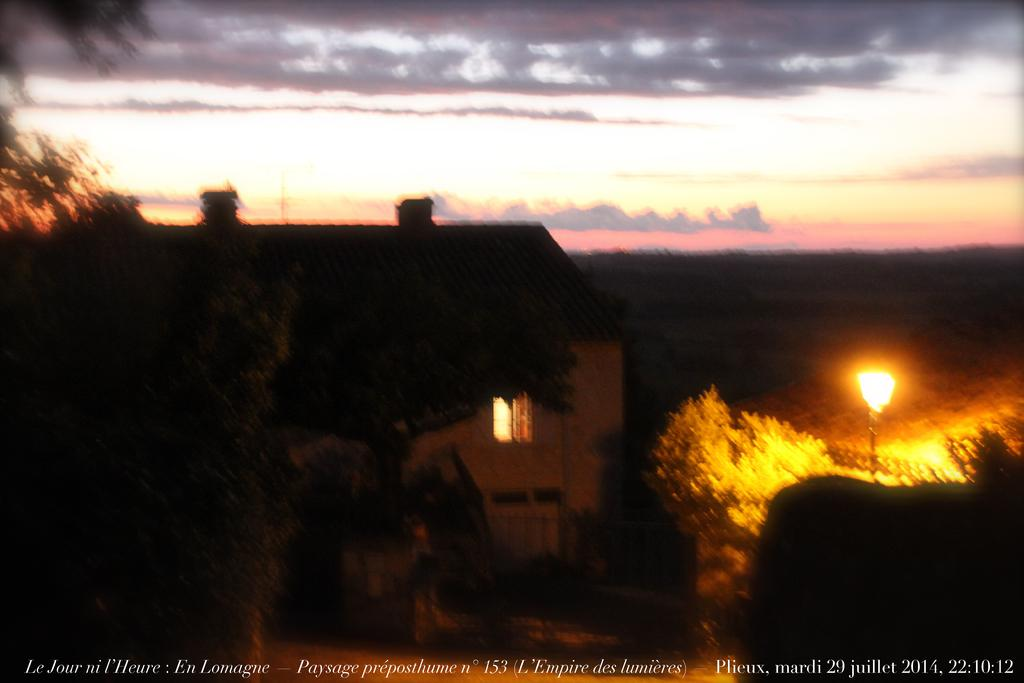What type of structure is visible in the image? The image contains a building with light. Where is the light pole located in the image? The light pole is on the right side of the image. What type of natural elements can be seen in the image? Trees are present in the image. What can be seen in the distance in the image? The sky is visible in the background of the image. What type of vessel is being used to transport the drum in the image? There is no vessel or drum present in the image. What do you believe the purpose of the light pole is in the image? The purpose of the light pole is to provide illumination, as it is a common function of light poles. 